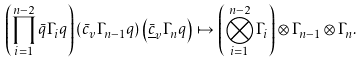Convert formula to latex. <formula><loc_0><loc_0><loc_500><loc_500>\left ( \prod _ { i = 1 } ^ { n - 2 } \bar { q } \Gamma _ { i } q \right ) \left ( { \bar { c } } _ { v } \Gamma _ { n - 1 } q \right ) \left ( { \bar { \underline { c } } } _ { v } \Gamma _ { n } q \right ) \mapsto \left ( \bigotimes _ { i = 1 } ^ { n - 2 } \Gamma _ { i } \right ) \otimes \Gamma _ { n - 1 } \otimes \Gamma _ { n } .</formula> 